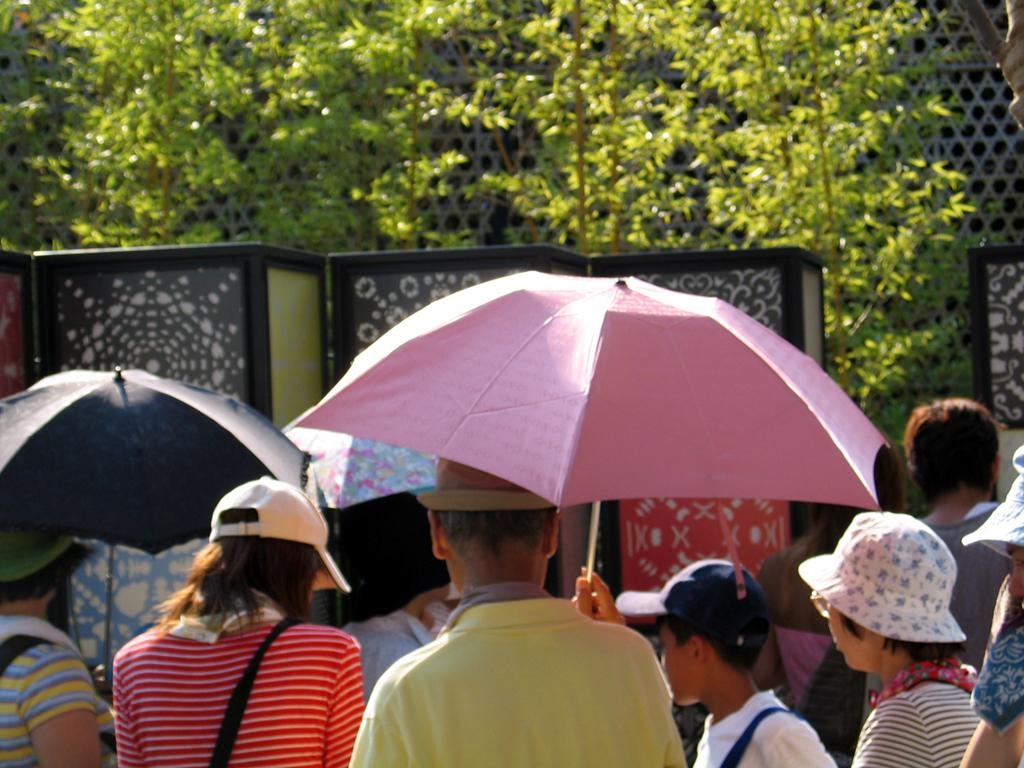What is the main subject of the image? The main subject of the image is a group of people. What objects are being used by the people in the image? There are umbrellas in the image. What can be seen in the background of the image? There is mesh and trees in the background of the image. What type of question is being asked in the image? There is no question being asked in the image; it features a group of people with umbrellas in front of a background with mesh and trees. 